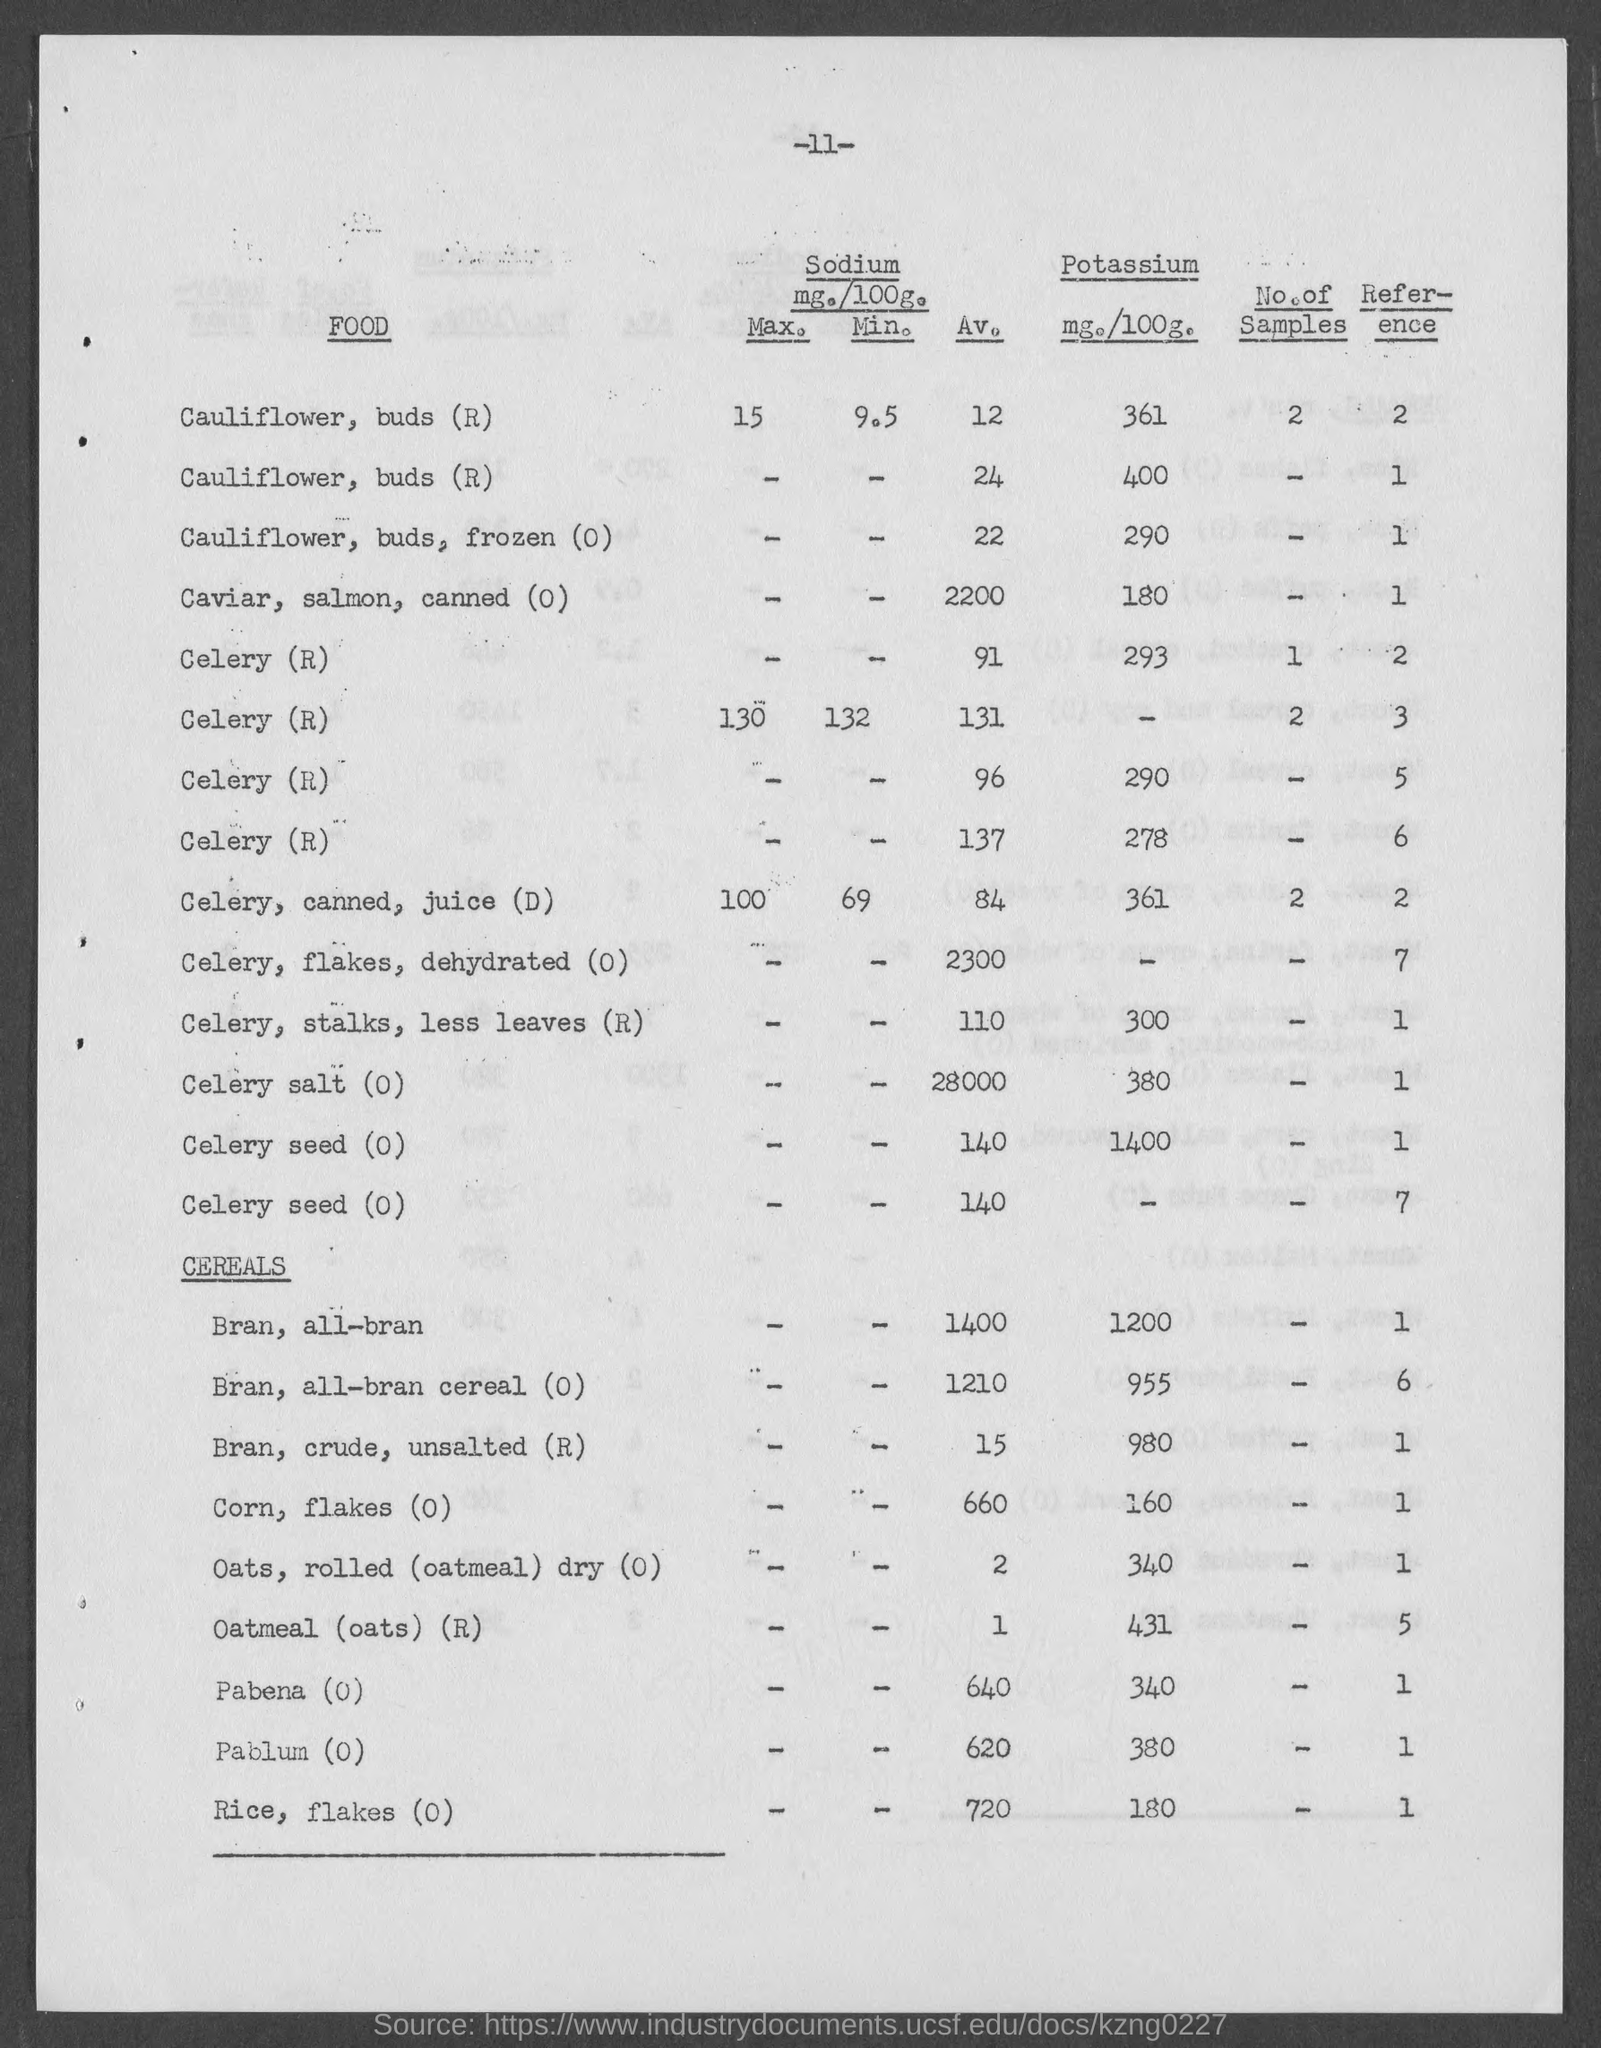What is the number mentioned at the top of the document?
Give a very brief answer. 11. For "cauliflower, buds (r)" having "Av." "Sodium" value "12",  what is the "mg./100g." value of "potassium"?
Your answer should be compact. 361. Which "food" has the highest "potassium" content as per the given table?
Give a very brief answer. Celery seed (O). What is the "Av." "Sodium" value in "mg/100g" for "Celery, flakes, dehydrated (O)"?
Make the answer very short. 2300. What is the last "Reference" value given?
Ensure brevity in your answer.  1. Which is the largest value in the "No. of Samples" column?
Ensure brevity in your answer.  2. What is the "Reference" value for the entry just above the subheading "cereals"?
Offer a very short reply. 7. Which "Food" has no value entered in the "mg./100g." Of "Potassium" column only?
Offer a terse response. CELERY (R). 